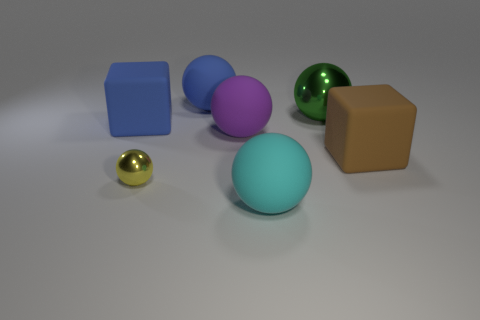Is the number of big cyan balls to the left of the yellow metallic object less than the number of cyan things?
Offer a very short reply. Yes. How big is the rubber cube on the left side of the shiny thing in front of the big matte cube that is on the right side of the tiny thing?
Your answer should be compact. Large. The large matte object that is both behind the large purple object and in front of the big metal ball is what color?
Your answer should be compact. Blue. What number of brown cylinders are there?
Give a very brief answer. 0. Is there any other thing that has the same size as the yellow sphere?
Offer a terse response. No. Is the large green sphere made of the same material as the yellow sphere?
Give a very brief answer. Yes. There is a blue matte object that is to the right of the small thing; is it the same size as the metallic sphere to the left of the large cyan rubber object?
Offer a very short reply. No. Is the number of cyan matte spheres less than the number of rubber balls?
Provide a short and direct response. Yes. How many rubber objects are big cylinders or cyan objects?
Offer a very short reply. 1. There is a big matte cube to the left of the cyan object; are there any blue matte objects behind it?
Ensure brevity in your answer.  Yes. 